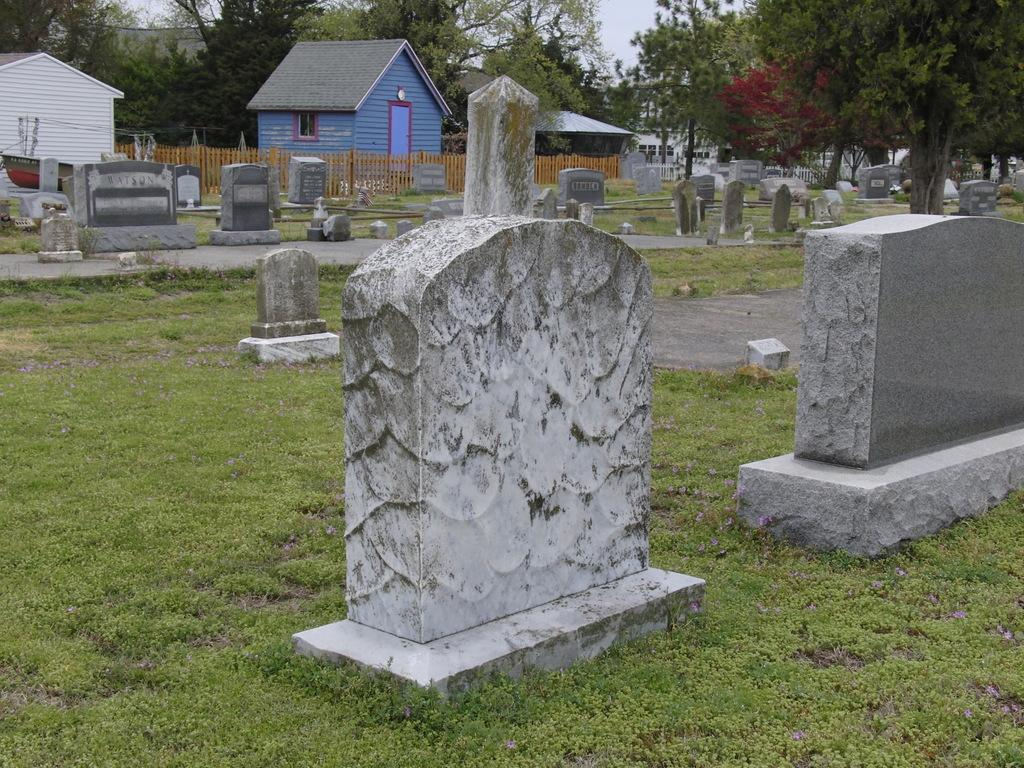What type of structures can be seen in the image? There are buildings in the image. What natural elements are present in the image? There are trees and grass in the image. What man-made feature can be seen in the image? There is a railing in the image. What type of grave markers are visible in the image? There are tombstones in the image. What part of the sky is visible in the image? The sky is visible at the top of the image. What type of surface is present at the bottom of the image? There is a pavement at the bottom of the image. Can you tell me how many vests are hanging on the railing in the image? There is no mention of vests in the image, so it is not possible to answer that question. What type of animals can be seen in the zoo depicted in the image? There is no zoo present in the image. 